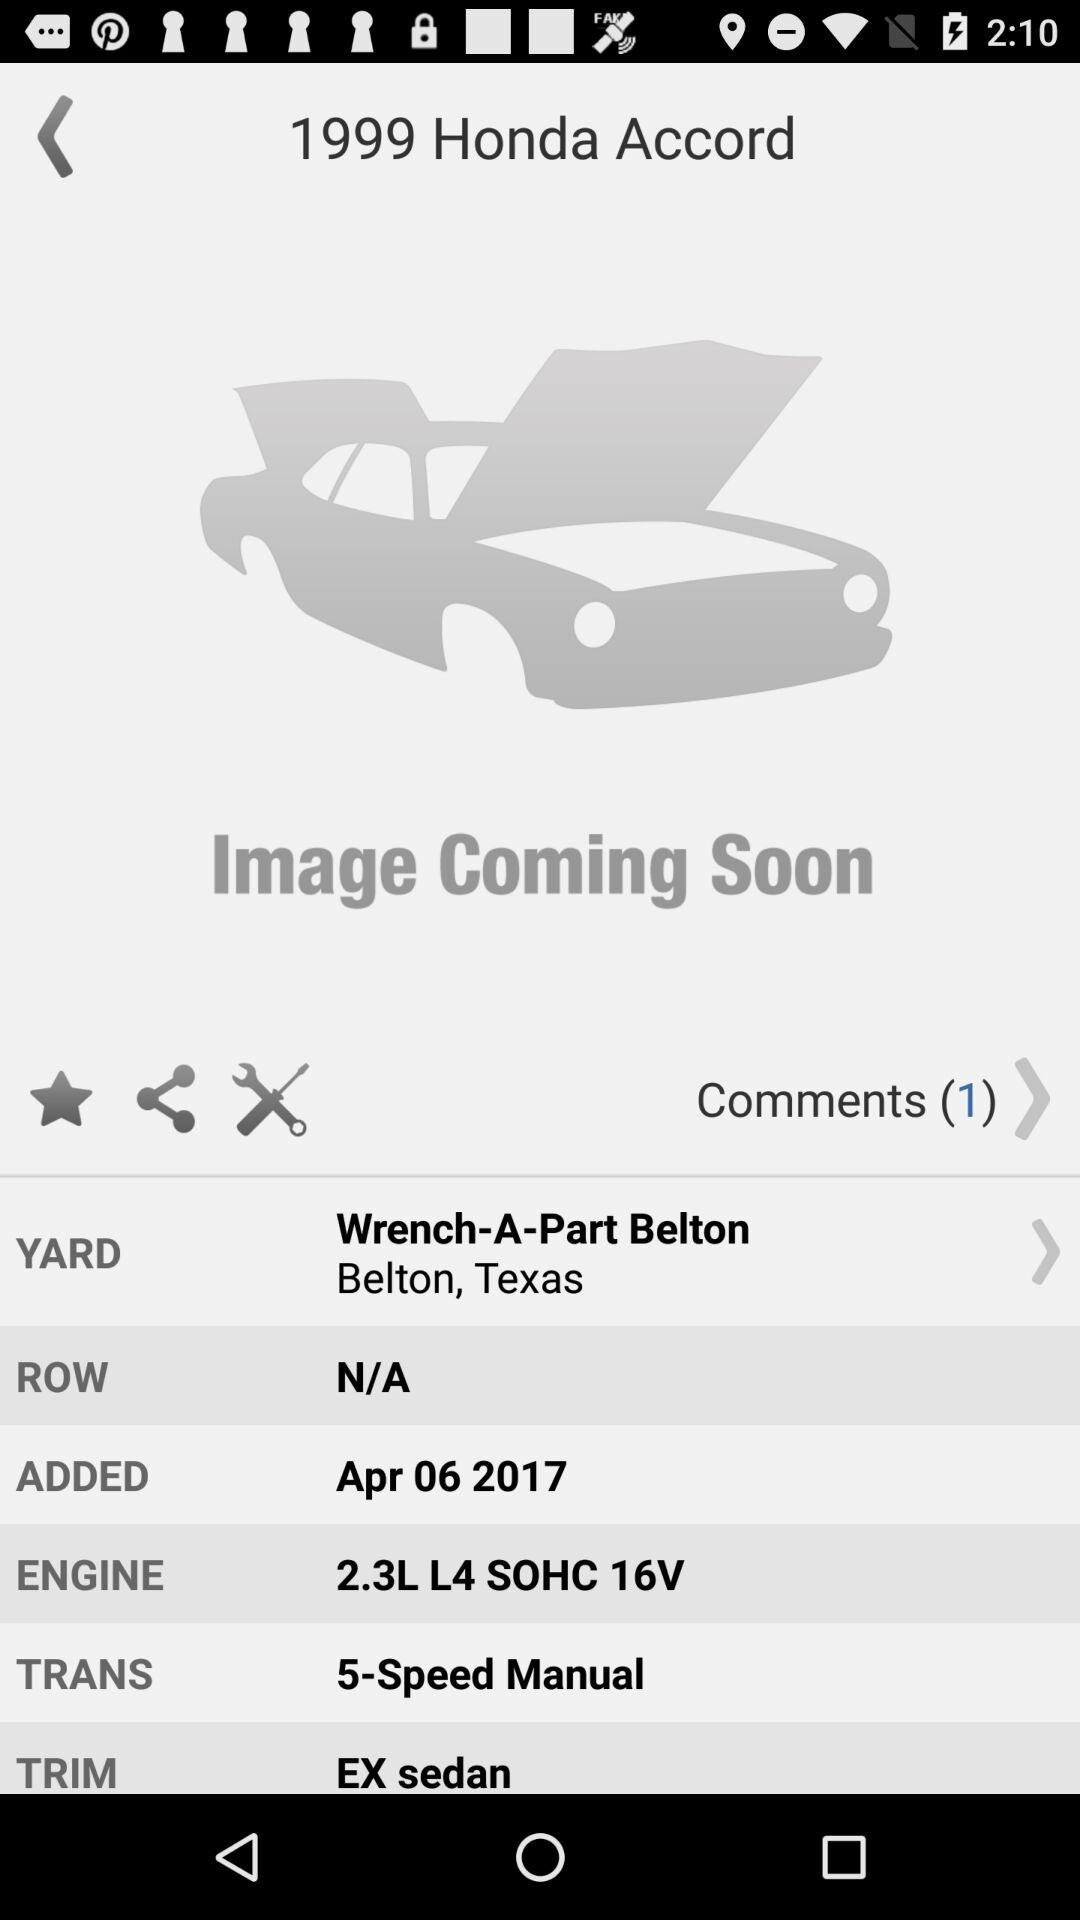How many comments are there? There are 1 comments. 